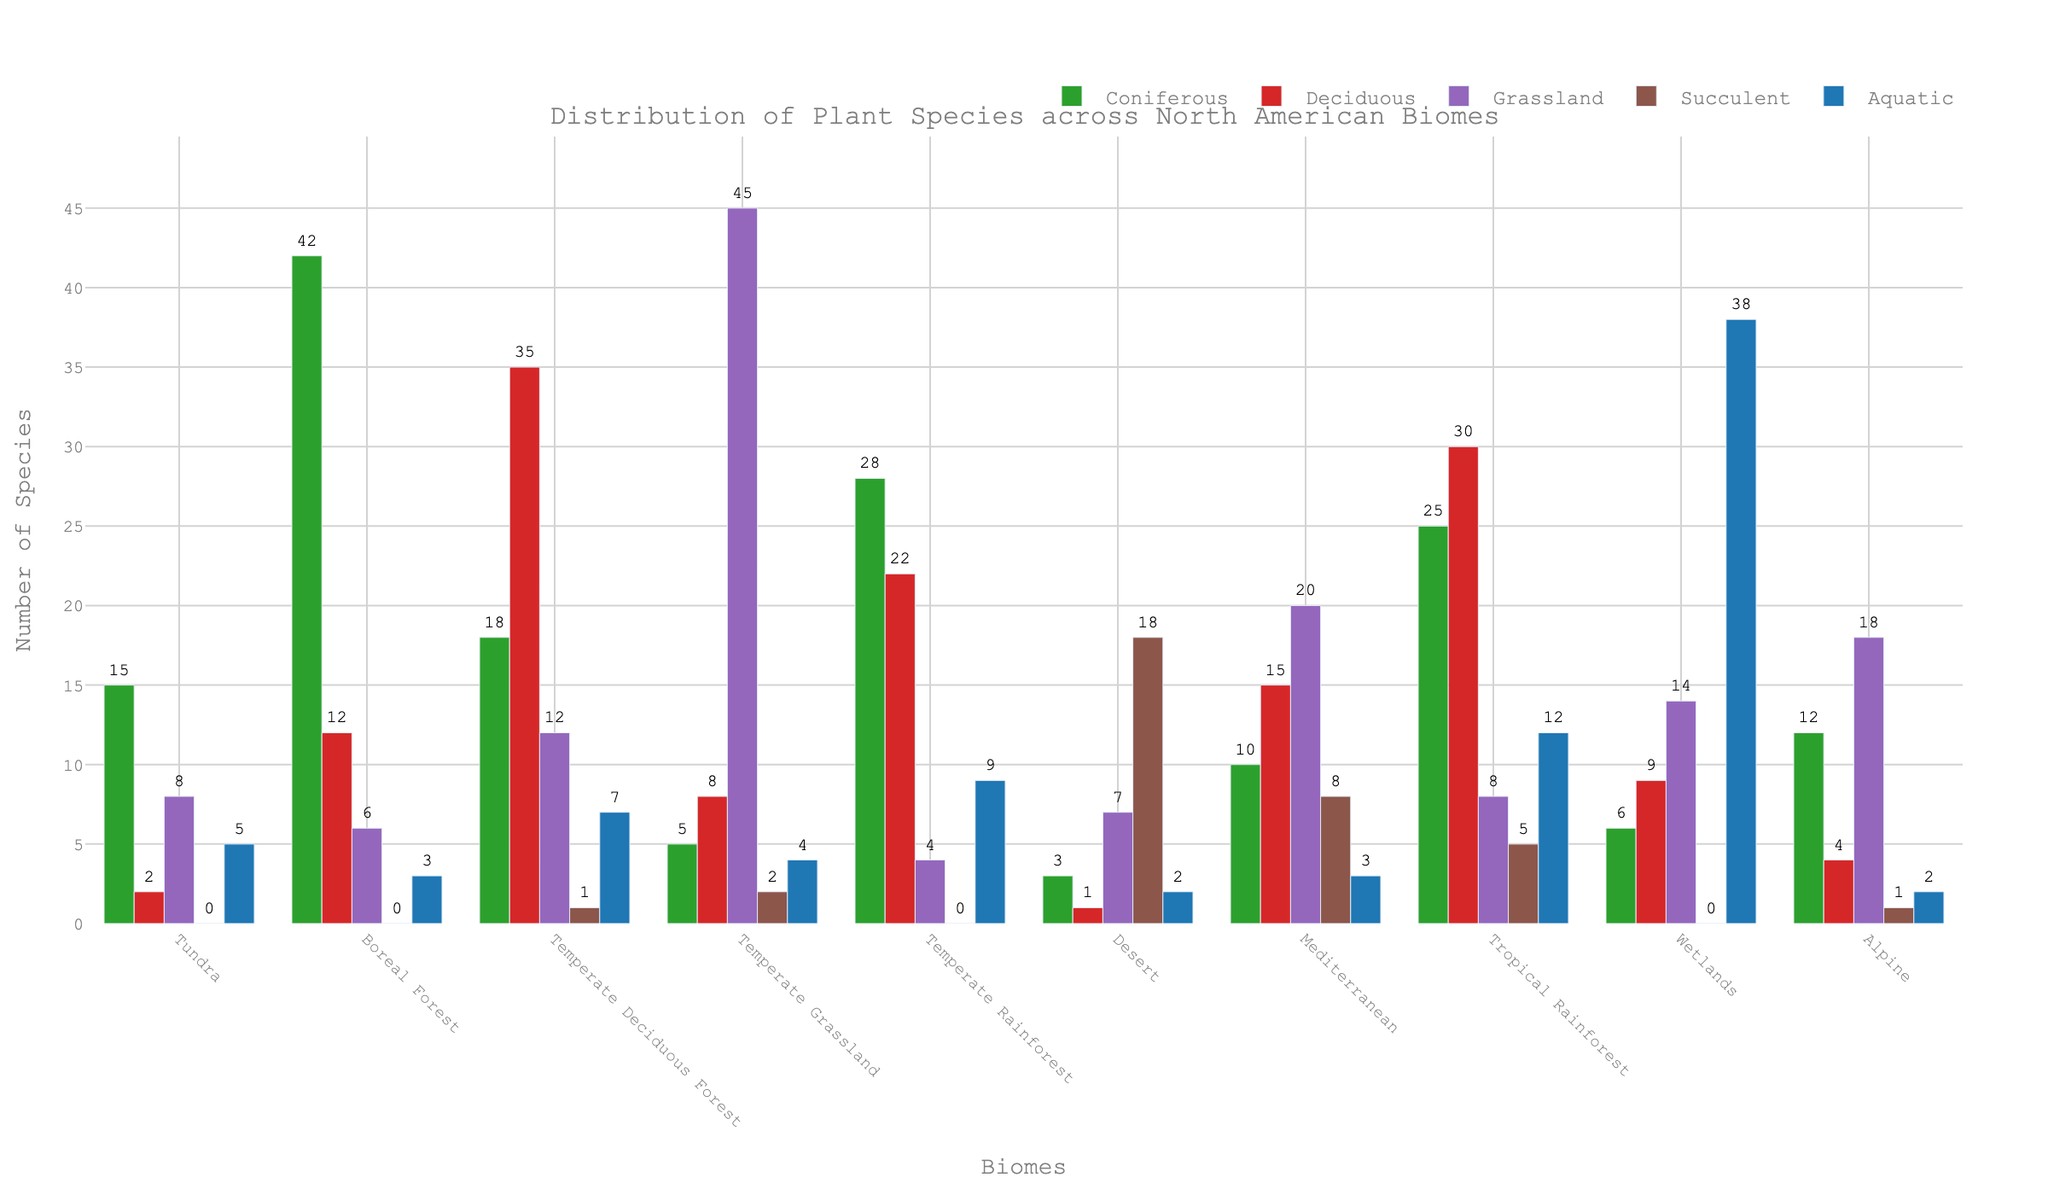Which biome has the highest number of coniferous species? Looking at the height of the green bars, the Boreal Forest has the tallest green bar representing the coniferous species.
Answer: Boreal Forest Which biome has more deciduous species: the Temperate Deciduous Forest or the Tropical Rainforest? Comparing the red bars of the two biomes, the Temperate Deciduous Forest has a taller red bar than the Tropical Rainforest.
Answer: Temperate Deciduous Forest How many more species are there in the wetlands compared to the alpine biome for aquatic plants? The aquatic species count for wetlands is 38 and for the alpine biome is 2. The difference is 38 - 2 = 36.
Answer: 36 Which biome has the least number of succulent species? Looking at the brown bars, the Tundra and Boreal Forest have bars with a value of 0 for succulent species, indicating that no succulent species are present in these biomes.
Answer: Tundra and Boreal Forest What is the total number of grassland species across the Desert and Mediterranean biomes? The grassland species in the Desert biome are 7 and in the Mediterranean biome are 20. Summing them gives 7 + 20 = 27.
Answer: 27 Which biome has a higher average number of species: Boreal Forest or Alpine? Calculating the average for Boreal: (42 + 12 + 6 + 0 + 3)/5 = 12.6. For Alpine: (12 + 4 + 18 + 1 + 2)/5 = 7.4. Therefore, Boreal Forest has a higher average number.
Answer: Boreal Forest Are there more aquatic species in the Tropical Rainforest or the Temperate Rainforest? Comparing the blue bars representing aquatic species, the Tropical Rainforest has 12 and the Temperate Rainforest has 9. Therefore, the Tropical Rainforest has more aquatic species.
Answer: Tropical Rainforest What is the sum of all the plant species in the Tundra biome? Summing up all species in the Tundra biome: 15 + 2 + 8 + 0 + 5 = 30.
Answer: 30 Is the number of succulent species in the Desert greater than the number of grassland species in the Temperate Deciduous Forest? The succulent species in the Desert count is 18, whereas the grassland species in the Temperate Deciduous Forest is 12. Since 18 is greater than 12, the answer is yes.
Answer: Yes 